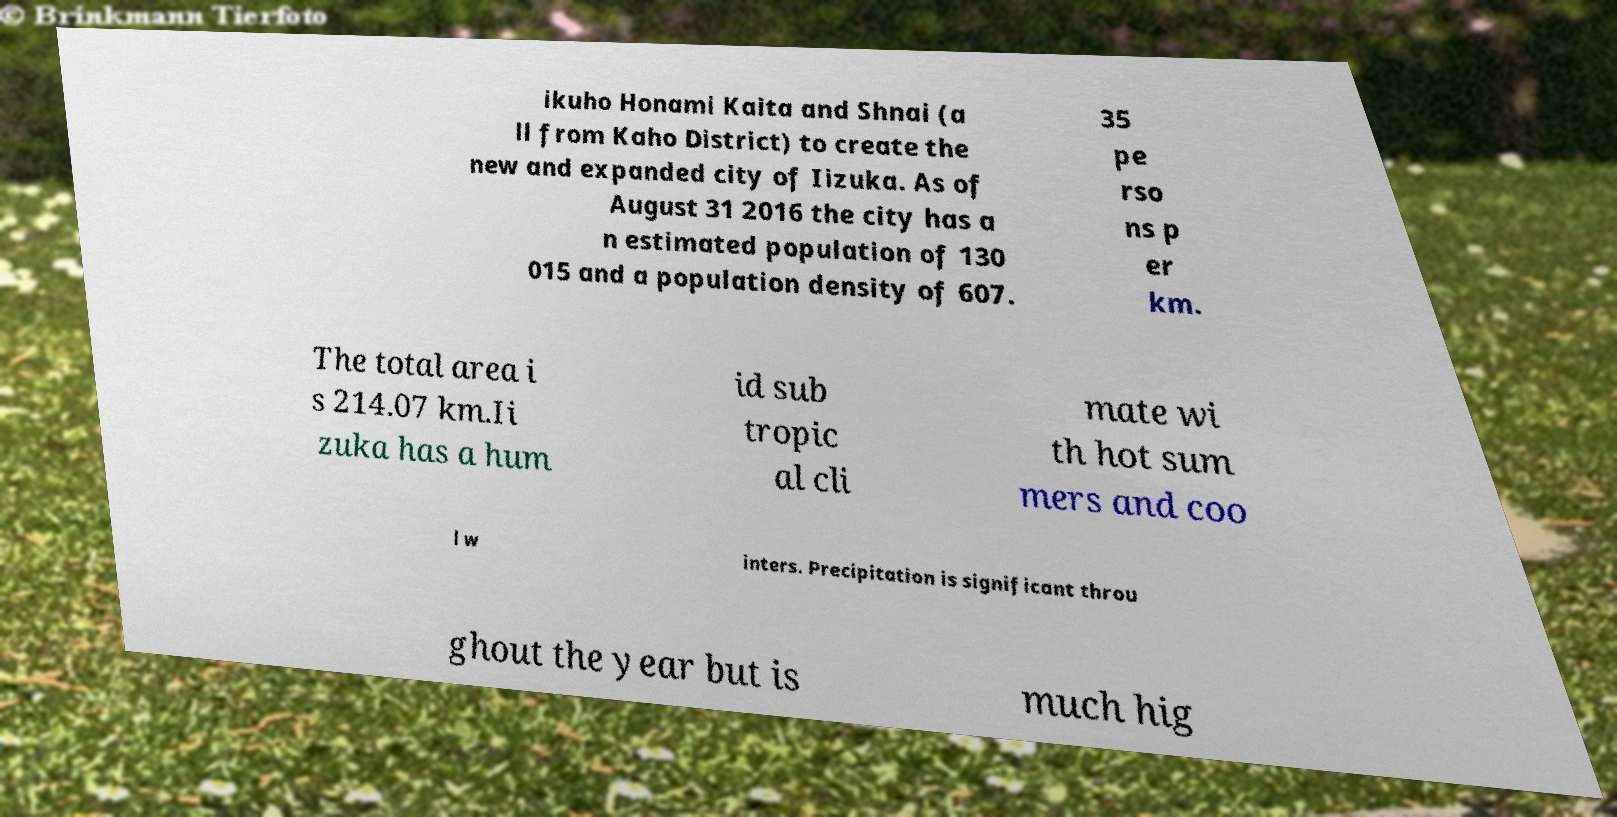Please read and relay the text visible in this image. What does it say? ikuho Honami Kaita and Shnai (a ll from Kaho District) to create the new and expanded city of Iizuka. As of August 31 2016 the city has a n estimated population of 130 015 and a population density of 607. 35 pe rso ns p er km. The total area i s 214.07 km.Ii zuka has a hum id sub tropic al cli mate wi th hot sum mers and coo l w inters. Precipitation is significant throu ghout the year but is much hig 